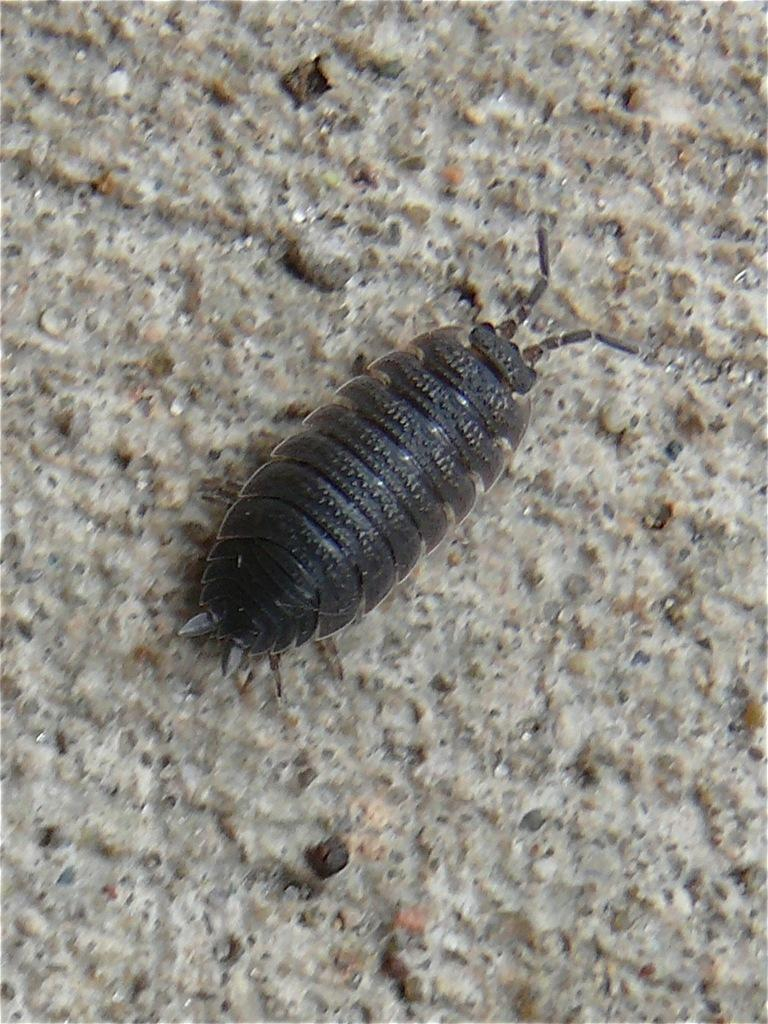What type of creature is present in the image? There is an insect in the image. What color is the insect? The insect is black in color. What is the background or surface on which the insect is located? The insect is on an ash-colored surface. What type of apparel is the insect wearing in the image? Insects do not wear apparel, so this question cannot be answered. 